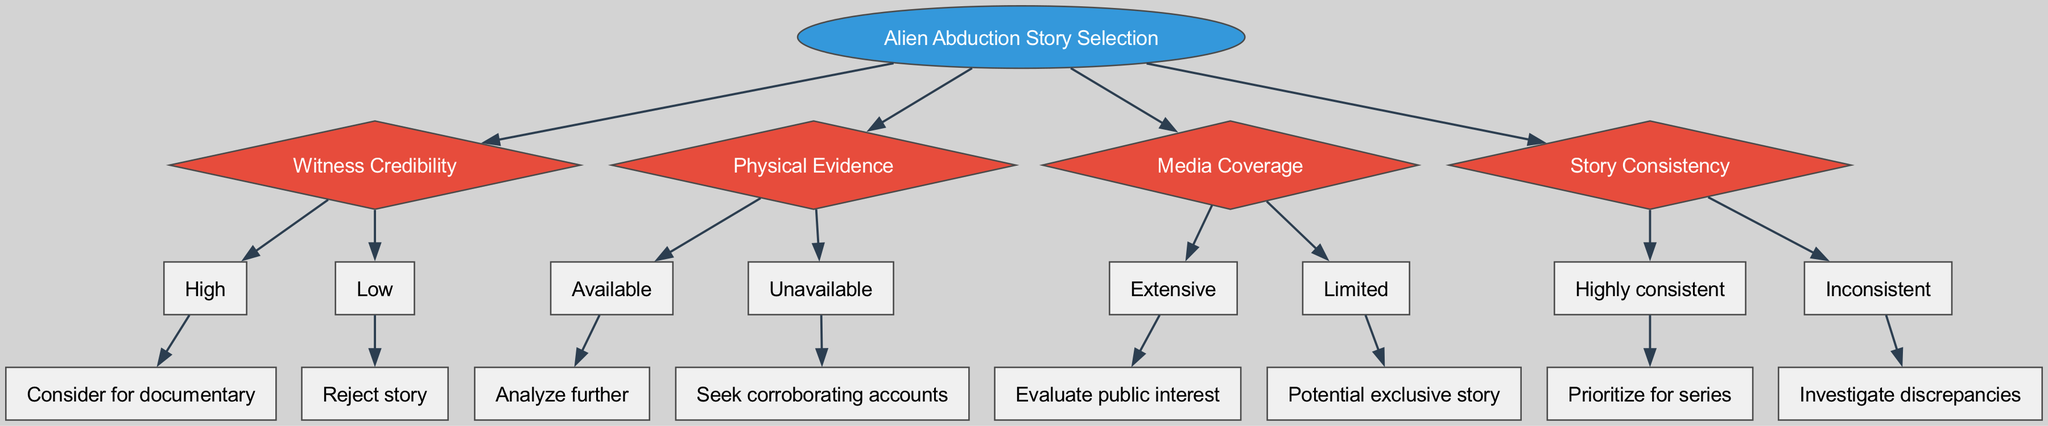What is the root node of the decision tree? The root node is labeled “Alien Abduction Story Selection”, representing the main focus of the decision-making process regarding the selection of stories.
Answer: Alien Abduction Story Selection How many main criteria are there to evaluate the abduction stories? There are four main criteria listed in the diagram: Witness Credibility, Physical Evidence, Media Coverage, and Story Consistency.
Answer: 4 What action is taken if witness credibility is low? If witness credibility is low, the action taken is to "Reject story". This shows that stories from unreliable witnesses are not considered.
Answer: Reject story If physical evidence is available, what is the next step in the decision tree? If physical evidence is available, the next step is to "Analyze further", indicating that stories with evidence deserve more in-depth exploration.
Answer: Analyze further What do you do if the media coverage of a story is extensive? If the media coverage of a story is extensive, the next step is to "Evaluate public interest", suggesting an assessment of how much the public might care about the story.
Answer: Evaluate public interest What conclusion is drawn from a highly consistent story? A highly consistent story is prioritized for the series, meaning that it is considered stronger and more credible compared to the rest.
Answer: Prioritize for series What happens if there is no physical evidence? If there is no physical evidence, the action is to "Seek corroborating accounts", meaning that further verification of the story through additional accounts is necessary.
Answer: Seek corroborating accounts How is an inconsistent story treated in this decision tree? An inconsistent story triggers an investigation of discrepancies, indicating a need for further scrutiny due to its lack of reliability.
Answer: Investigate discrepancies What is inferred about stories that have limited media coverage? Stories with limited media coverage are noted as having the potential to be an exclusive story, suggesting they might be more unique or underreported.
Answer: Potential exclusive story 